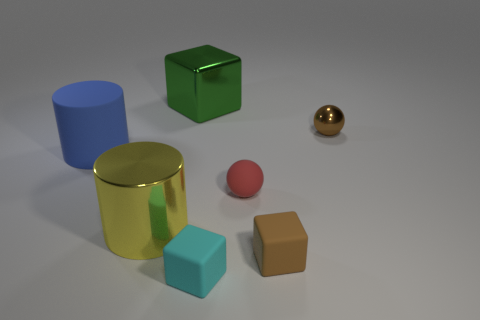Add 1 shiny cylinders. How many objects exist? 8 Subtract all balls. How many objects are left? 5 Subtract 1 green blocks. How many objects are left? 6 Subtract all green blocks. Subtract all metal cylinders. How many objects are left? 5 Add 7 small cyan matte things. How many small cyan matte things are left? 8 Add 1 red things. How many red things exist? 2 